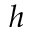Convert formula to latex. <formula><loc_0><loc_0><loc_500><loc_500>h</formula> 